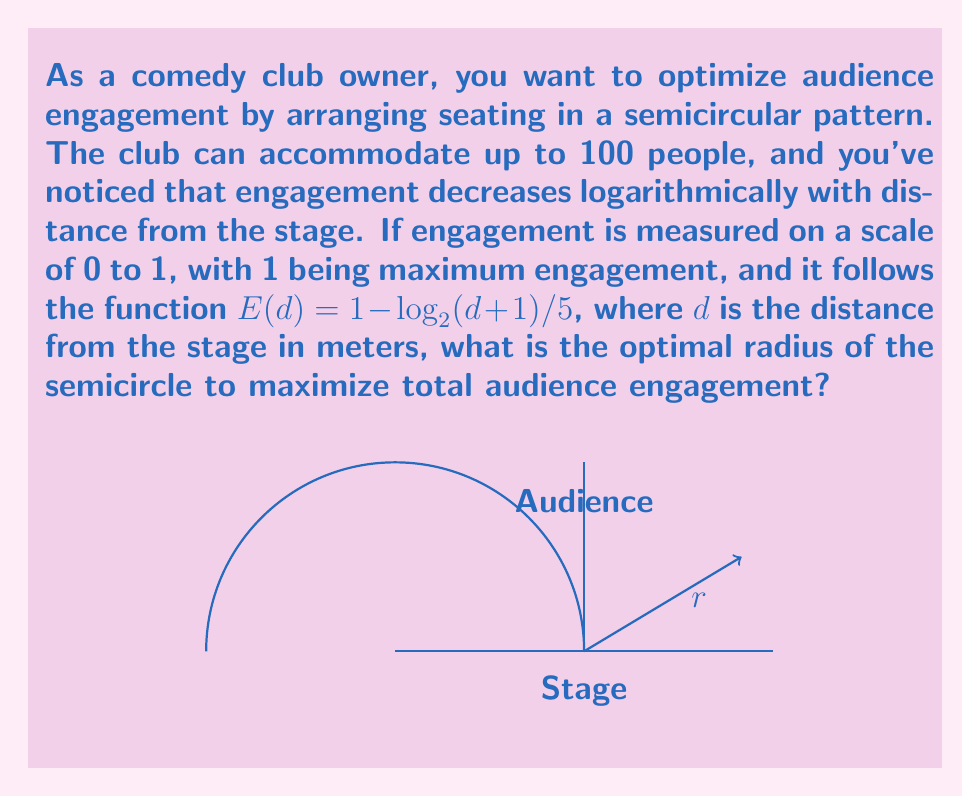Can you answer this question? Let's approach this step-by-step:

1) First, we need to express the total engagement as a function of the radius $r$. The area of a semicircle with radius $r$ is $\frac{\pi r^2}{2}$.

2) Assuming uniform audience density, the number of people at distance $d$ from the stage is proportional to the circumference at that distance, which is $\pi d$.

3) The total engagement $E_{total}$ is the integral of the engagement function multiplied by the number of people at each distance:

   $$E_{total}(r) = \int_0^r \pi d \cdot (1 - \frac{\log_2(d+1)}{5}) \, dd$$

4) To maximize this, we need to find the value of $r$ where the derivative of $E_{total}(r)$ is zero:

   $$\frac{d}{dr}E_{total}(r) = \pi r \cdot (1 - \frac{\log_2(r+1)}{5}) = 0$$

5) Solving this equation:

   $$1 - \frac{\log_2(r+1)}{5} = 0$$
   $$\log_2(r+1) = 5$$
   $$r+1 = 2^5 = 32$$
   $$r = 31$$

6) To verify this is a maximum, we can check that the second derivative is negative at this point.

7) Finally, we need to check if this radius allows for 100 people. The area of the semicircle is:

   $$A = \frac{\pi r^2}{2} = \frac{\pi \cdot 31^2}{2} \approx 1510 \, m^2$$

   Assuming each person needs about 1 $m^2$ of space, this arrangement can accommodate more than 100 people.

Therefore, the optimal radius is 31 meters.
Answer: 31 meters 